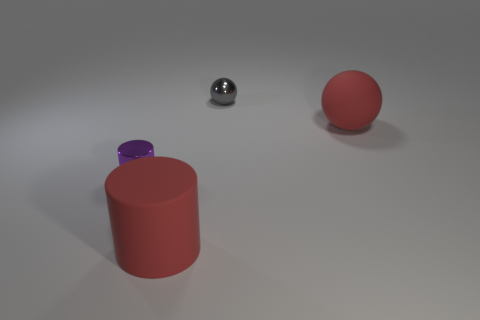How does the surface texture of the objects compare? The sphere and the cylinder have a matte finish, giving them a non-reflective surface, while the small sphere has a glossy, reflective surface. 